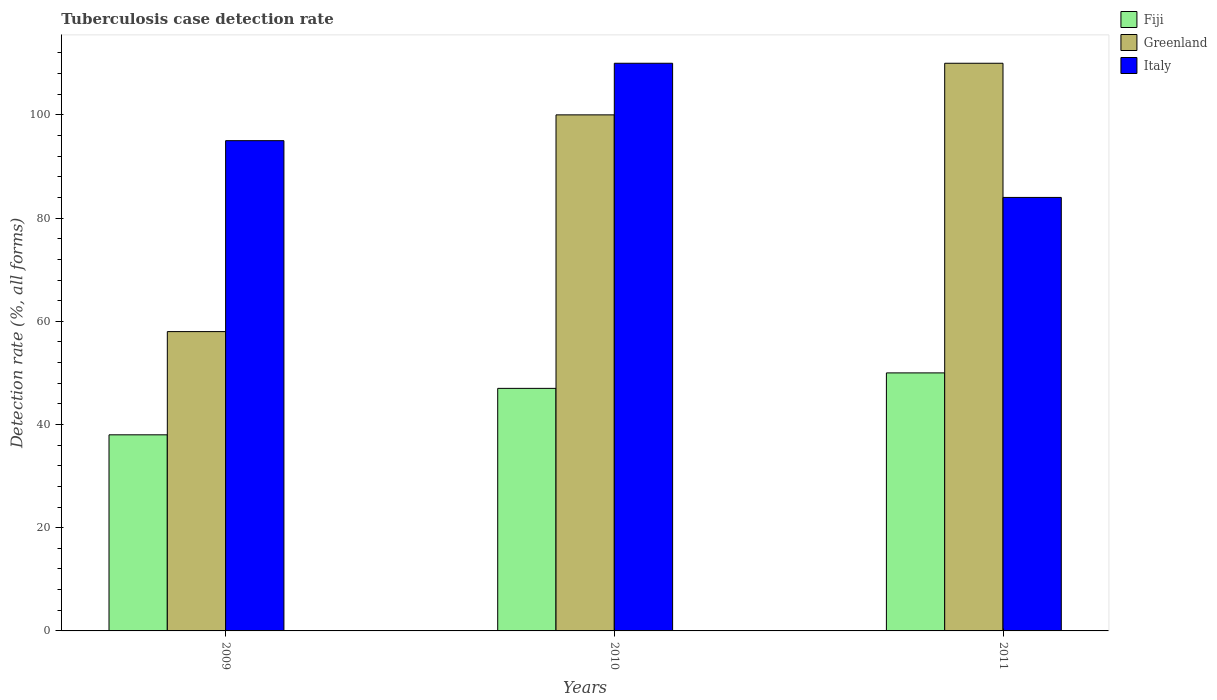How many different coloured bars are there?
Your answer should be very brief. 3. How many groups of bars are there?
Your response must be concise. 3. Are the number of bars per tick equal to the number of legend labels?
Provide a short and direct response. Yes. In how many cases, is the number of bars for a given year not equal to the number of legend labels?
Your answer should be compact. 0. What is the tuberculosis case detection rate in in Greenland in 2009?
Your answer should be compact. 58. Across all years, what is the maximum tuberculosis case detection rate in in Greenland?
Keep it short and to the point. 110. In which year was the tuberculosis case detection rate in in Fiji maximum?
Your answer should be compact. 2011. In which year was the tuberculosis case detection rate in in Greenland minimum?
Give a very brief answer. 2009. What is the total tuberculosis case detection rate in in Greenland in the graph?
Ensure brevity in your answer.  268. What is the difference between the tuberculosis case detection rate in in Fiji in 2009 and that in 2011?
Provide a succinct answer. -12. What is the average tuberculosis case detection rate in in Greenland per year?
Ensure brevity in your answer.  89.33. In the year 2009, what is the difference between the tuberculosis case detection rate in in Italy and tuberculosis case detection rate in in Greenland?
Your answer should be very brief. 37. In how many years, is the tuberculosis case detection rate in in Italy greater than 8 %?
Give a very brief answer. 3. What is the ratio of the tuberculosis case detection rate in in Italy in 2009 to that in 2010?
Give a very brief answer. 0.86. What is the difference between the highest and the lowest tuberculosis case detection rate in in Fiji?
Ensure brevity in your answer.  12. In how many years, is the tuberculosis case detection rate in in Italy greater than the average tuberculosis case detection rate in in Italy taken over all years?
Provide a succinct answer. 1. What does the 2nd bar from the left in 2009 represents?
Keep it short and to the point. Greenland. What does the 3rd bar from the right in 2009 represents?
Keep it short and to the point. Fiji. Is it the case that in every year, the sum of the tuberculosis case detection rate in in Greenland and tuberculosis case detection rate in in Italy is greater than the tuberculosis case detection rate in in Fiji?
Offer a terse response. Yes. How many years are there in the graph?
Ensure brevity in your answer.  3. Are the values on the major ticks of Y-axis written in scientific E-notation?
Provide a succinct answer. No. How many legend labels are there?
Your answer should be compact. 3. What is the title of the graph?
Ensure brevity in your answer.  Tuberculosis case detection rate. Does "Angola" appear as one of the legend labels in the graph?
Ensure brevity in your answer.  No. What is the label or title of the Y-axis?
Make the answer very short. Detection rate (%, all forms). What is the Detection rate (%, all forms) in Fiji in 2009?
Offer a terse response. 38. What is the Detection rate (%, all forms) of Greenland in 2009?
Your answer should be compact. 58. What is the Detection rate (%, all forms) in Italy in 2010?
Provide a short and direct response. 110. What is the Detection rate (%, all forms) of Fiji in 2011?
Provide a short and direct response. 50. What is the Detection rate (%, all forms) of Greenland in 2011?
Give a very brief answer. 110. What is the Detection rate (%, all forms) in Italy in 2011?
Provide a succinct answer. 84. Across all years, what is the maximum Detection rate (%, all forms) in Greenland?
Offer a terse response. 110. Across all years, what is the maximum Detection rate (%, all forms) in Italy?
Offer a terse response. 110. Across all years, what is the minimum Detection rate (%, all forms) of Fiji?
Provide a short and direct response. 38. Across all years, what is the minimum Detection rate (%, all forms) in Greenland?
Provide a short and direct response. 58. What is the total Detection rate (%, all forms) in Fiji in the graph?
Offer a very short reply. 135. What is the total Detection rate (%, all forms) in Greenland in the graph?
Ensure brevity in your answer.  268. What is the total Detection rate (%, all forms) of Italy in the graph?
Provide a short and direct response. 289. What is the difference between the Detection rate (%, all forms) in Greenland in 2009 and that in 2010?
Your answer should be compact. -42. What is the difference between the Detection rate (%, all forms) in Italy in 2009 and that in 2010?
Provide a short and direct response. -15. What is the difference between the Detection rate (%, all forms) in Greenland in 2009 and that in 2011?
Make the answer very short. -52. What is the difference between the Detection rate (%, all forms) in Fiji in 2010 and that in 2011?
Provide a succinct answer. -3. What is the difference between the Detection rate (%, all forms) in Greenland in 2010 and that in 2011?
Offer a terse response. -10. What is the difference between the Detection rate (%, all forms) of Fiji in 2009 and the Detection rate (%, all forms) of Greenland in 2010?
Provide a short and direct response. -62. What is the difference between the Detection rate (%, all forms) in Fiji in 2009 and the Detection rate (%, all forms) in Italy in 2010?
Offer a terse response. -72. What is the difference between the Detection rate (%, all forms) in Greenland in 2009 and the Detection rate (%, all forms) in Italy in 2010?
Give a very brief answer. -52. What is the difference between the Detection rate (%, all forms) of Fiji in 2009 and the Detection rate (%, all forms) of Greenland in 2011?
Ensure brevity in your answer.  -72. What is the difference between the Detection rate (%, all forms) in Fiji in 2009 and the Detection rate (%, all forms) in Italy in 2011?
Your answer should be compact. -46. What is the difference between the Detection rate (%, all forms) of Fiji in 2010 and the Detection rate (%, all forms) of Greenland in 2011?
Provide a succinct answer. -63. What is the difference between the Detection rate (%, all forms) of Fiji in 2010 and the Detection rate (%, all forms) of Italy in 2011?
Offer a very short reply. -37. What is the difference between the Detection rate (%, all forms) in Greenland in 2010 and the Detection rate (%, all forms) in Italy in 2011?
Your answer should be compact. 16. What is the average Detection rate (%, all forms) of Greenland per year?
Offer a terse response. 89.33. What is the average Detection rate (%, all forms) of Italy per year?
Keep it short and to the point. 96.33. In the year 2009, what is the difference between the Detection rate (%, all forms) in Fiji and Detection rate (%, all forms) in Greenland?
Make the answer very short. -20. In the year 2009, what is the difference between the Detection rate (%, all forms) in Fiji and Detection rate (%, all forms) in Italy?
Make the answer very short. -57. In the year 2009, what is the difference between the Detection rate (%, all forms) of Greenland and Detection rate (%, all forms) of Italy?
Give a very brief answer. -37. In the year 2010, what is the difference between the Detection rate (%, all forms) in Fiji and Detection rate (%, all forms) in Greenland?
Give a very brief answer. -53. In the year 2010, what is the difference between the Detection rate (%, all forms) of Fiji and Detection rate (%, all forms) of Italy?
Make the answer very short. -63. In the year 2011, what is the difference between the Detection rate (%, all forms) of Fiji and Detection rate (%, all forms) of Greenland?
Provide a succinct answer. -60. In the year 2011, what is the difference between the Detection rate (%, all forms) of Fiji and Detection rate (%, all forms) of Italy?
Give a very brief answer. -34. In the year 2011, what is the difference between the Detection rate (%, all forms) in Greenland and Detection rate (%, all forms) in Italy?
Give a very brief answer. 26. What is the ratio of the Detection rate (%, all forms) in Fiji in 2009 to that in 2010?
Ensure brevity in your answer.  0.81. What is the ratio of the Detection rate (%, all forms) of Greenland in 2009 to that in 2010?
Your answer should be very brief. 0.58. What is the ratio of the Detection rate (%, all forms) of Italy in 2009 to that in 2010?
Provide a succinct answer. 0.86. What is the ratio of the Detection rate (%, all forms) in Fiji in 2009 to that in 2011?
Keep it short and to the point. 0.76. What is the ratio of the Detection rate (%, all forms) in Greenland in 2009 to that in 2011?
Offer a terse response. 0.53. What is the ratio of the Detection rate (%, all forms) of Italy in 2009 to that in 2011?
Keep it short and to the point. 1.13. What is the ratio of the Detection rate (%, all forms) of Italy in 2010 to that in 2011?
Your answer should be very brief. 1.31. What is the difference between the highest and the second highest Detection rate (%, all forms) in Fiji?
Make the answer very short. 3. What is the difference between the highest and the second highest Detection rate (%, all forms) in Greenland?
Provide a short and direct response. 10. What is the difference between the highest and the lowest Detection rate (%, all forms) of Fiji?
Provide a succinct answer. 12. What is the difference between the highest and the lowest Detection rate (%, all forms) of Italy?
Give a very brief answer. 26. 